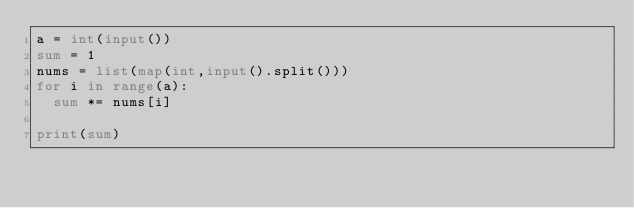Convert code to text. <code><loc_0><loc_0><loc_500><loc_500><_Python_>a = int(input())
sum = 1
nums = list(map(int,input().split()))
for i in range(a):
  sum *= nums[i]
  
print(sum)
</code> 